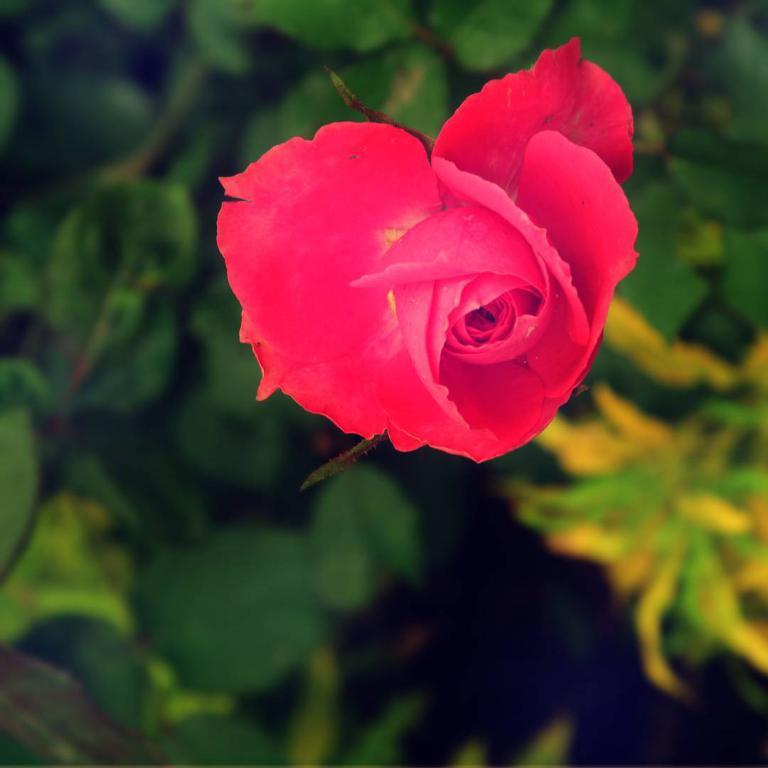What type of flower is in the image? There is a red color rose flower in the image. What can be seen in the background of the image? There are leaves in the background of the image. What type of bone can be seen in the image? There is no bone present in the image; it features a red color rose flower and leaves in the background. How many pies are visible in the image? There are no pies present in the image. 